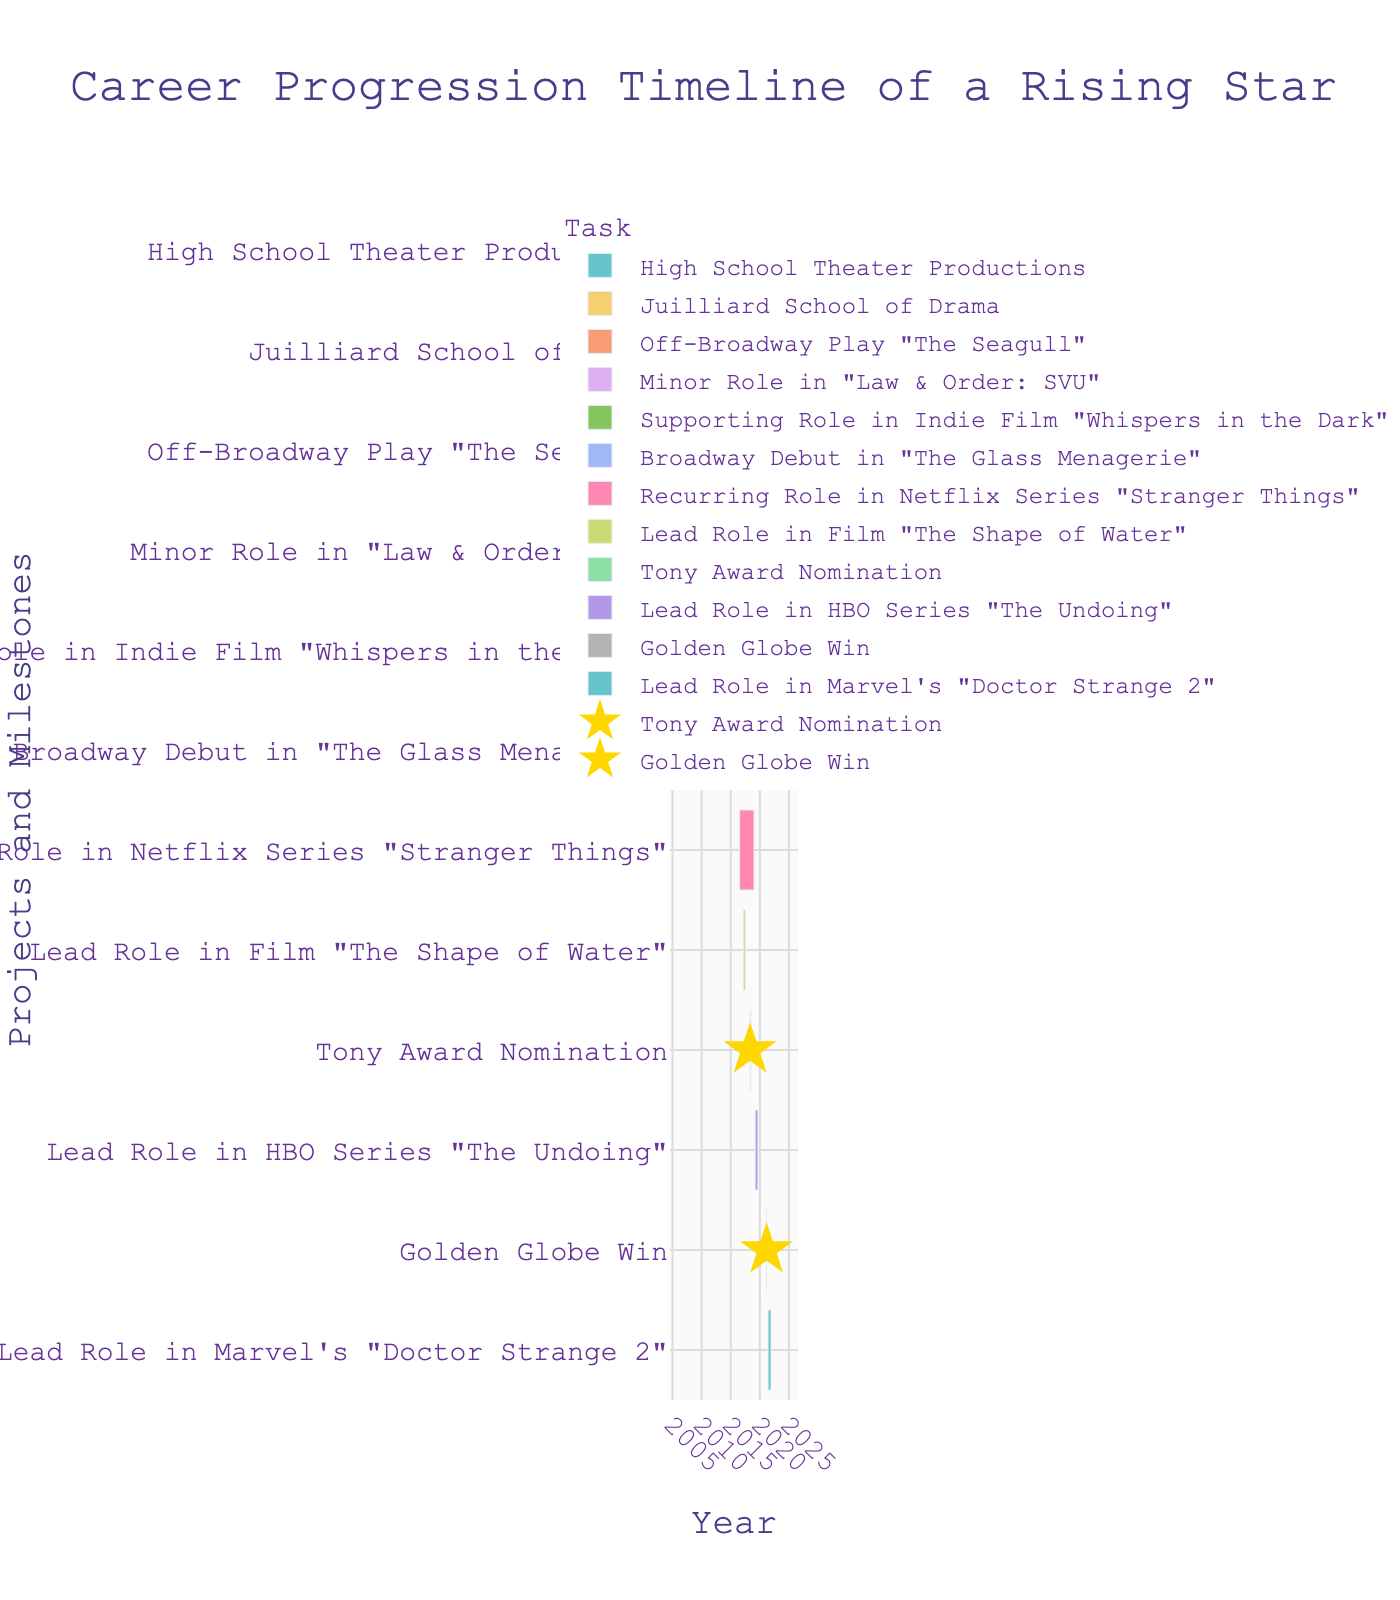What is the title of the timeline? The title is usually displayed prominently at the top of the figure. Here it is "Career Progression Timeline of a Rising Star."
Answer: Career Progression Timeline of a Rising Star When did the actor attend the Juilliard School of Drama? To find this, locate the bar labeled "Juilliard School of Drama." The Gantt chart will show the start and end dates.
Answer: September 1, 2009, to May 31, 2013 How long did the actor have a recurring role in Netflix's "Stranger Things"? Find the bar labeled "Recurring Role in Netflix Series 'Stranger Things'" and calculate the duration between the start date and the end date.
Answer: About 2.5 years (July 15, 2016, to December 31, 2018) Which project or milestone is marked with a glitter effect? Look for the events highlighted with star markers which indicate special achievements. Here, it includes "Tony Award Nomination" and "Golden Globe Win."
Answer: Tony Award Nomination and Golden Globe Win What is the earliest milestone in the actor's career on the timeline? The earliest milestone is typically the one at the top of the Gantt chart. Here, it is "High School Theater Productions."
Answer: High School Theater Productions Which project had a longer duration: "The Glass Menagerie" on Broadway or "The Shape of Water" film? Compare the lengths of the bars for "Broadway Debut in 'The Glass Menagerie'" and "Lead Role in Film 'The Shape of Water'." The duration can be calculated by subtracting the start date from the end date in each case.
Answer: The Glass Menagerie Which milestone happened in 2021? Scroll to the year 2021 on the time axis and read the labels associated with the bars for that year. Two events are in 2021: "Golden Globe Win" and "Lead Role in Marvel's 'Doctor Strange 2'."
Answer: Golden Globe Win and Lead Role in Marvel's "Doctor Strange 2" What is the total number of projects and milestones listed on the timeline? Count all the labeled bars on the Gantt chart. Each bar represents a project or milestone.
Answer: 11 Which came first: the supporting role in "Whispers in the Dark" or the Broadway debut in "The Glass Menagerie"? Look at the position of the bars and their start dates for "Supporting Role in Indie Film 'Whispers in the Dark'" and "Broadway Debut in 'The Glass Menagerie'."
Answer: Supporting Role in "Whispers in the Dark" How many years after high school theater productions did the actor make their Broadway debut? Check the end date of "High School Theater Productions" and the start date of "Broadway Debut in 'The Glass Menagerie'." Subtract the earlier year from the later year.
Answer: Around 5.5 years 